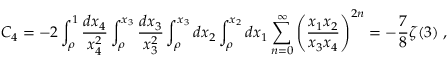Convert formula to latex. <formula><loc_0><loc_0><loc_500><loc_500>C _ { 4 } = - 2 \int _ { \rho } ^ { 1 } { \frac { d x _ { 4 } } { x _ { 4 } ^ { 2 } } } \int _ { \rho } ^ { x _ { 3 } } { \frac { d x _ { 3 } } { x _ { 3 } ^ { 2 } } } \int _ { \rho } ^ { x _ { 3 } } d x _ { 2 } \int _ { \rho } ^ { x _ { 2 } } d x _ { 1 } \sum _ { n = 0 } ^ { \infty } \left ( { \frac { x _ { 1 } x _ { 2 } } { x _ { 3 } x _ { 4 } } } \right ) ^ { 2 n } = - { \frac { 7 } { 8 } } \zeta ( 3 ) \, ,</formula> 